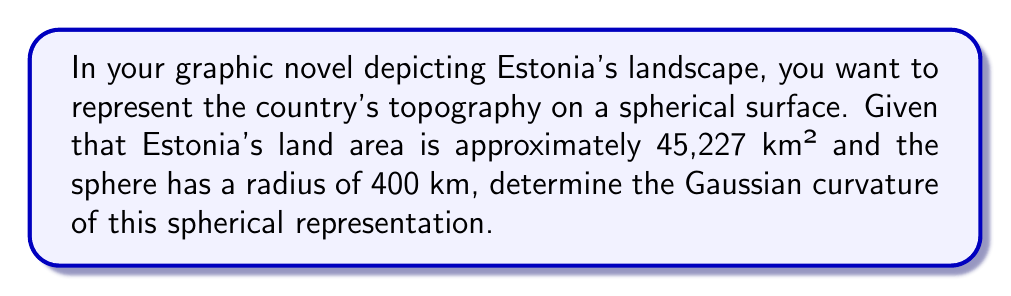Help me with this question. To solve this problem, we'll follow these steps:

1) Recall that the Gaussian curvature ($K$) of a sphere is constant and given by:

   $$K = \frac{1}{R^2}$$

   where $R$ is the radius of the sphere.

2) We're given that the radius of the sphere is 400 km. Let's substitute this into our equation:

   $$K = \frac{1}{(400\text{ km})^2}$$

3) Simplify:
   
   $$K = \frac{1}{160,000\text{ km}^2}$$

4) To express this in standard units (m⁻²), we need to convert km² to m²:
   
   $$K = \frac{1}{160,000 \times 1,000,000\text{ m}^2} = \frac{1}{160,000,000,000\text{ m}^2}$$

5) Simplify:

   $$K = 6.25 \times 10^{-12}\text{ m}^{-2}$$

This curvature represents how much the spherical surface deviates from a flat plane, which in this case would be a stylized representation of Estonia's landscape in your graphic novel.

[asy]
import geometry;

size(200);
draw(circle((0,0),4));
dot((0,0),red);
label("Center",(0,0),SW,red);
draw((0,0)--(4,0),Arrow);
label("R = 400 km",(2,0),S);
label("Spherical surface",(0,4),N);
[/asy]
Answer: $6.25 \times 10^{-12}\text{ m}^{-2}$ 